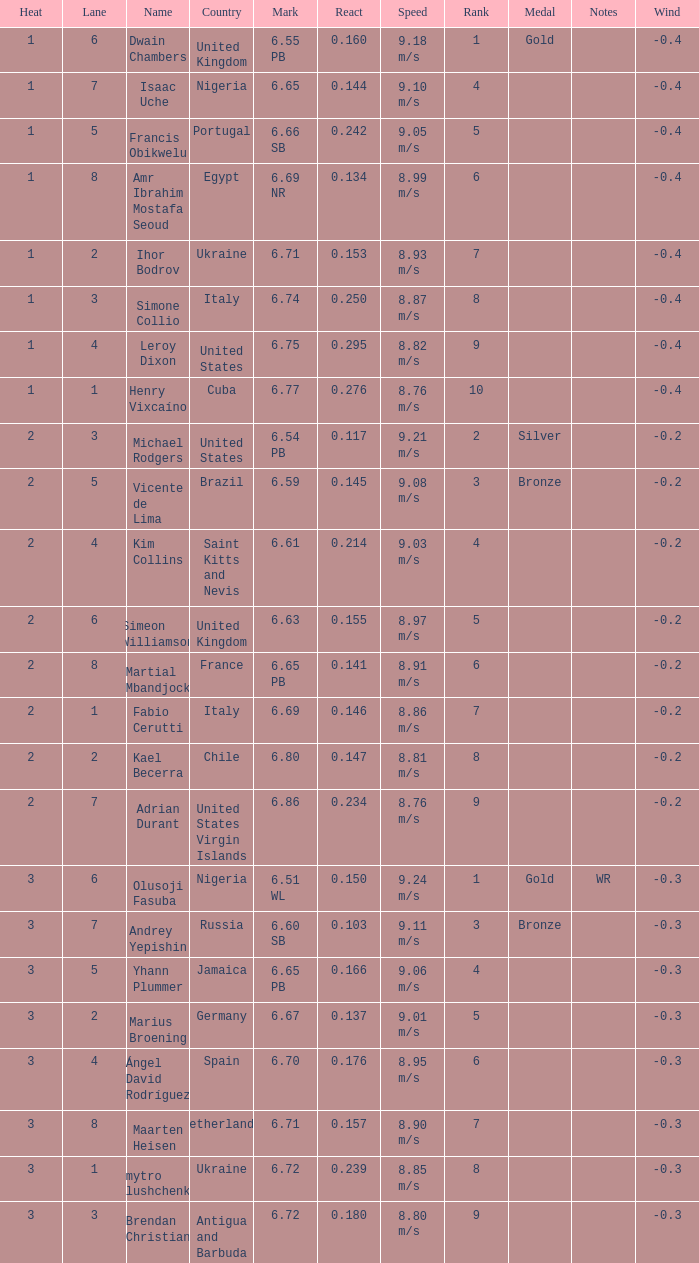What is Mark, when Name is Dmytro Hlushchenko? 6.72. 